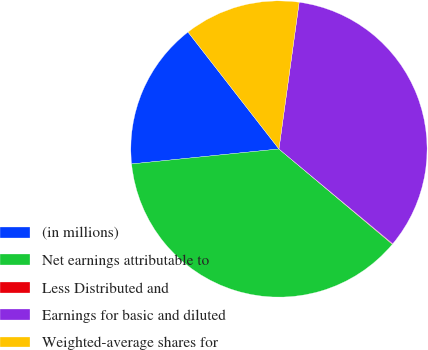Convert chart. <chart><loc_0><loc_0><loc_500><loc_500><pie_chart><fcel>(in millions)<fcel>Net earnings attributable to<fcel>Less Distributed and<fcel>Earnings for basic and diluted<fcel>Weighted-average shares for<nl><fcel>16.09%<fcel>37.27%<fcel>0.06%<fcel>33.88%<fcel>12.7%<nl></chart> 